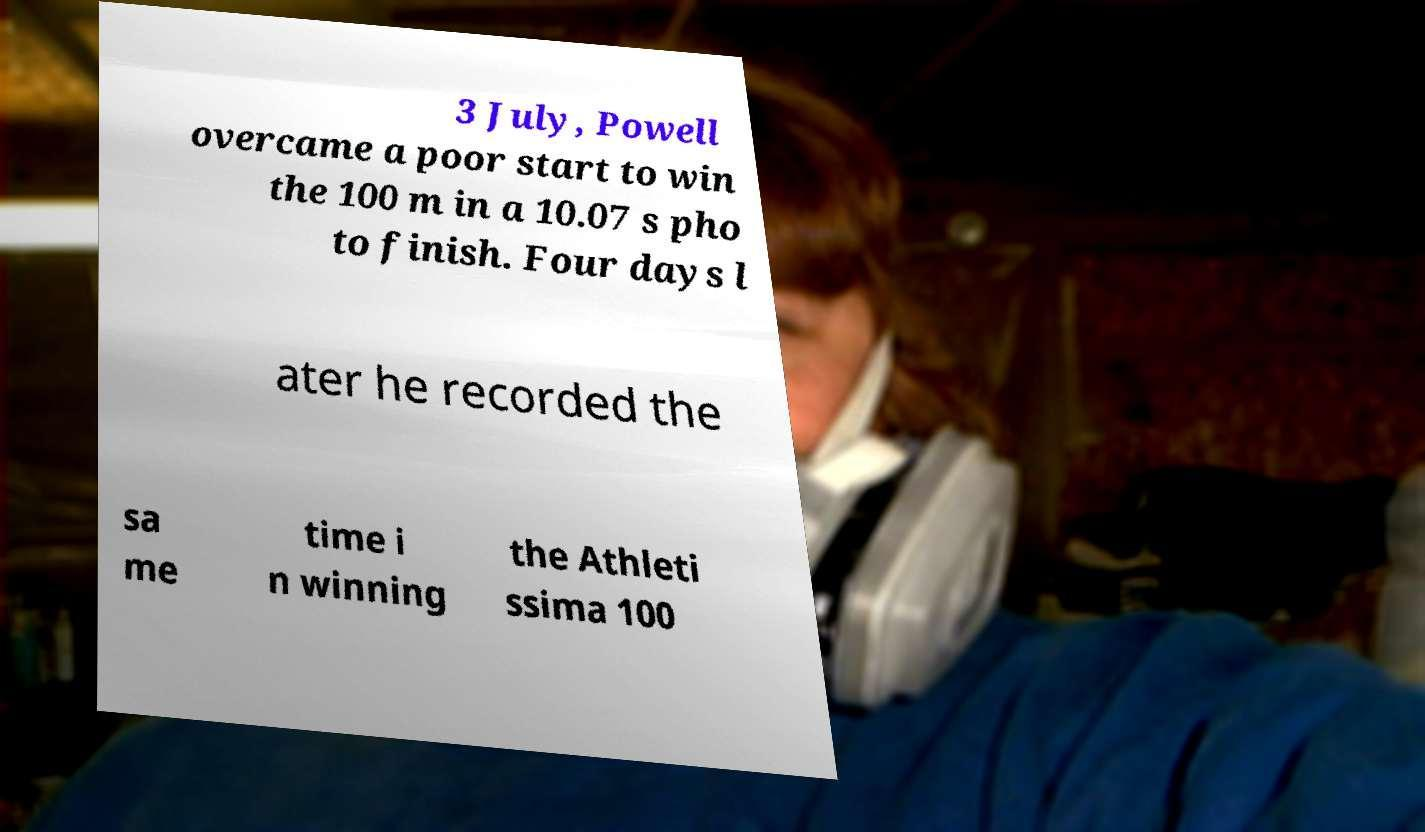Please read and relay the text visible in this image. What does it say? 3 July, Powell overcame a poor start to win the 100 m in a 10.07 s pho to finish. Four days l ater he recorded the sa me time i n winning the Athleti ssima 100 